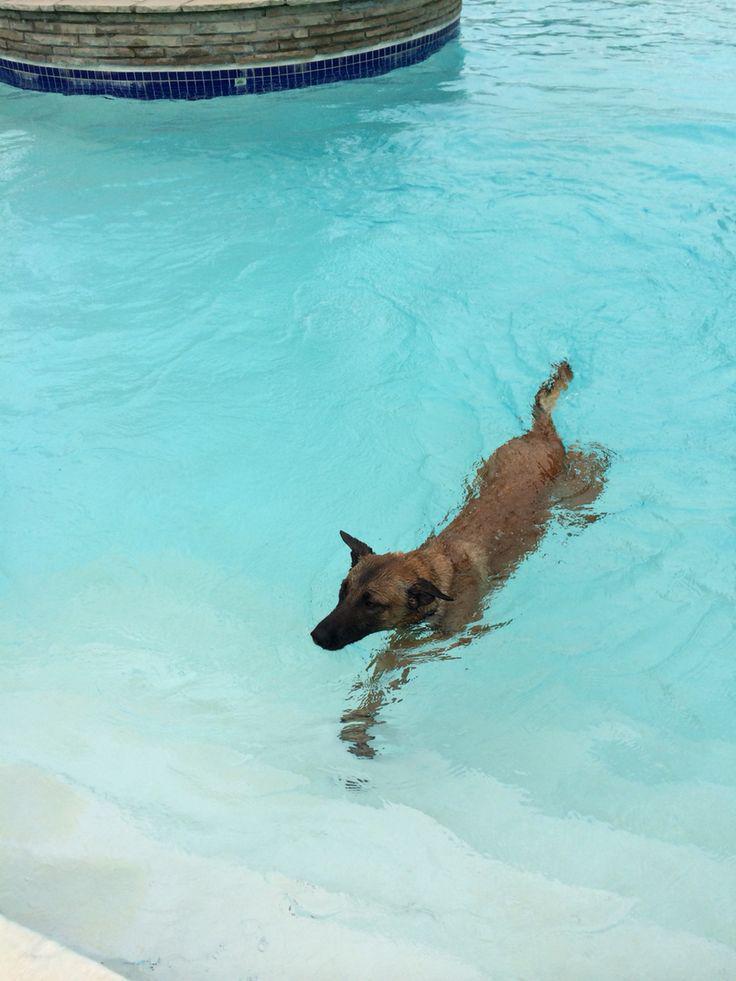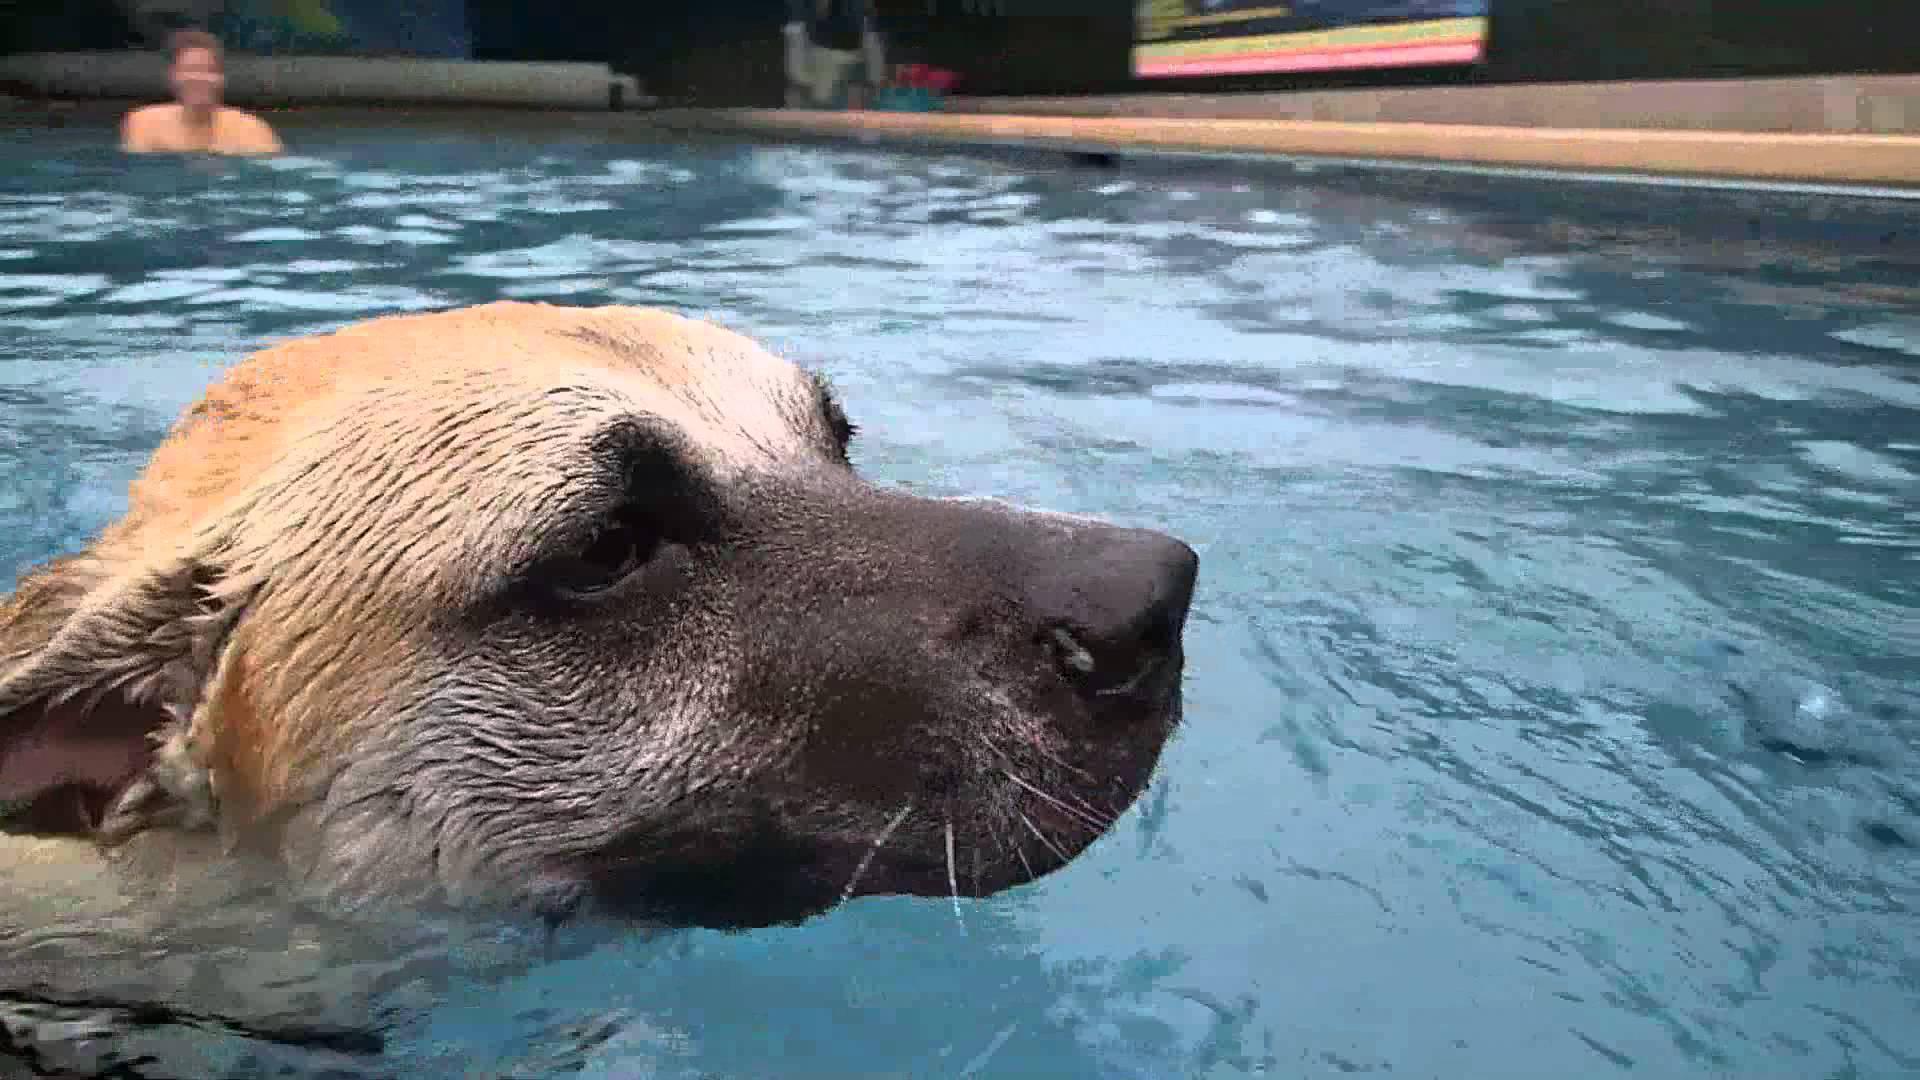The first image is the image on the left, the second image is the image on the right. Considering the images on both sides, is "Two dogs are in water." valid? Answer yes or no. Yes. 